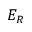Convert formula to latex. <formula><loc_0><loc_0><loc_500><loc_500>E _ { R }</formula> 